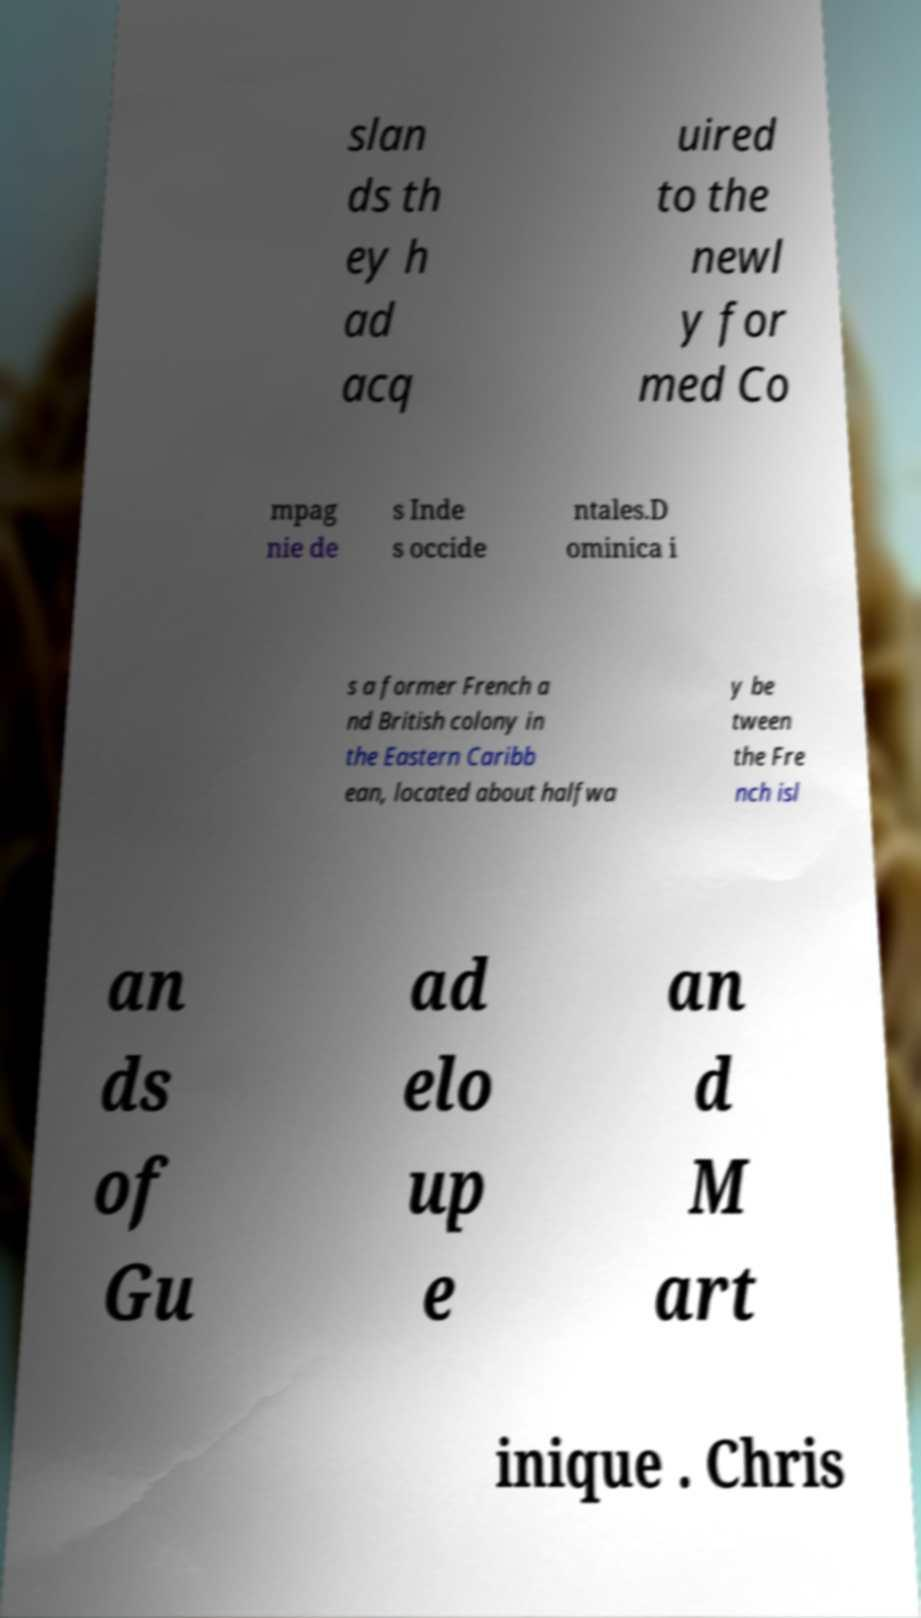What messages or text are displayed in this image? I need them in a readable, typed format. slan ds th ey h ad acq uired to the newl y for med Co mpag nie de s Inde s occide ntales.D ominica i s a former French a nd British colony in the Eastern Caribb ean, located about halfwa y be tween the Fre nch isl an ds of Gu ad elo up e an d M art inique . Chris 